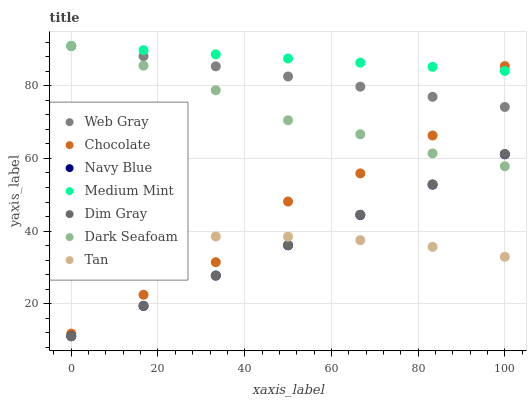Does Navy Blue have the minimum area under the curve?
Answer yes or no. Yes. Does Medium Mint have the maximum area under the curve?
Answer yes or no. Yes. Does Dim Gray have the minimum area under the curve?
Answer yes or no. No. Does Dim Gray have the maximum area under the curve?
Answer yes or no. No. Is Navy Blue the smoothest?
Answer yes or no. Yes. Is Chocolate the roughest?
Answer yes or no. Yes. Is Dim Gray the smoothest?
Answer yes or no. No. Is Dim Gray the roughest?
Answer yes or no. No. Does Dim Gray have the lowest value?
Answer yes or no. Yes. Does Chocolate have the lowest value?
Answer yes or no. No. Does Web Gray have the highest value?
Answer yes or no. Yes. Does Dim Gray have the highest value?
Answer yes or no. No. Is Dim Gray less than Chocolate?
Answer yes or no. Yes. Is Web Gray greater than Navy Blue?
Answer yes or no. Yes. Does Navy Blue intersect Tan?
Answer yes or no. Yes. Is Navy Blue less than Tan?
Answer yes or no. No. Is Navy Blue greater than Tan?
Answer yes or no. No. Does Dim Gray intersect Chocolate?
Answer yes or no. No. 